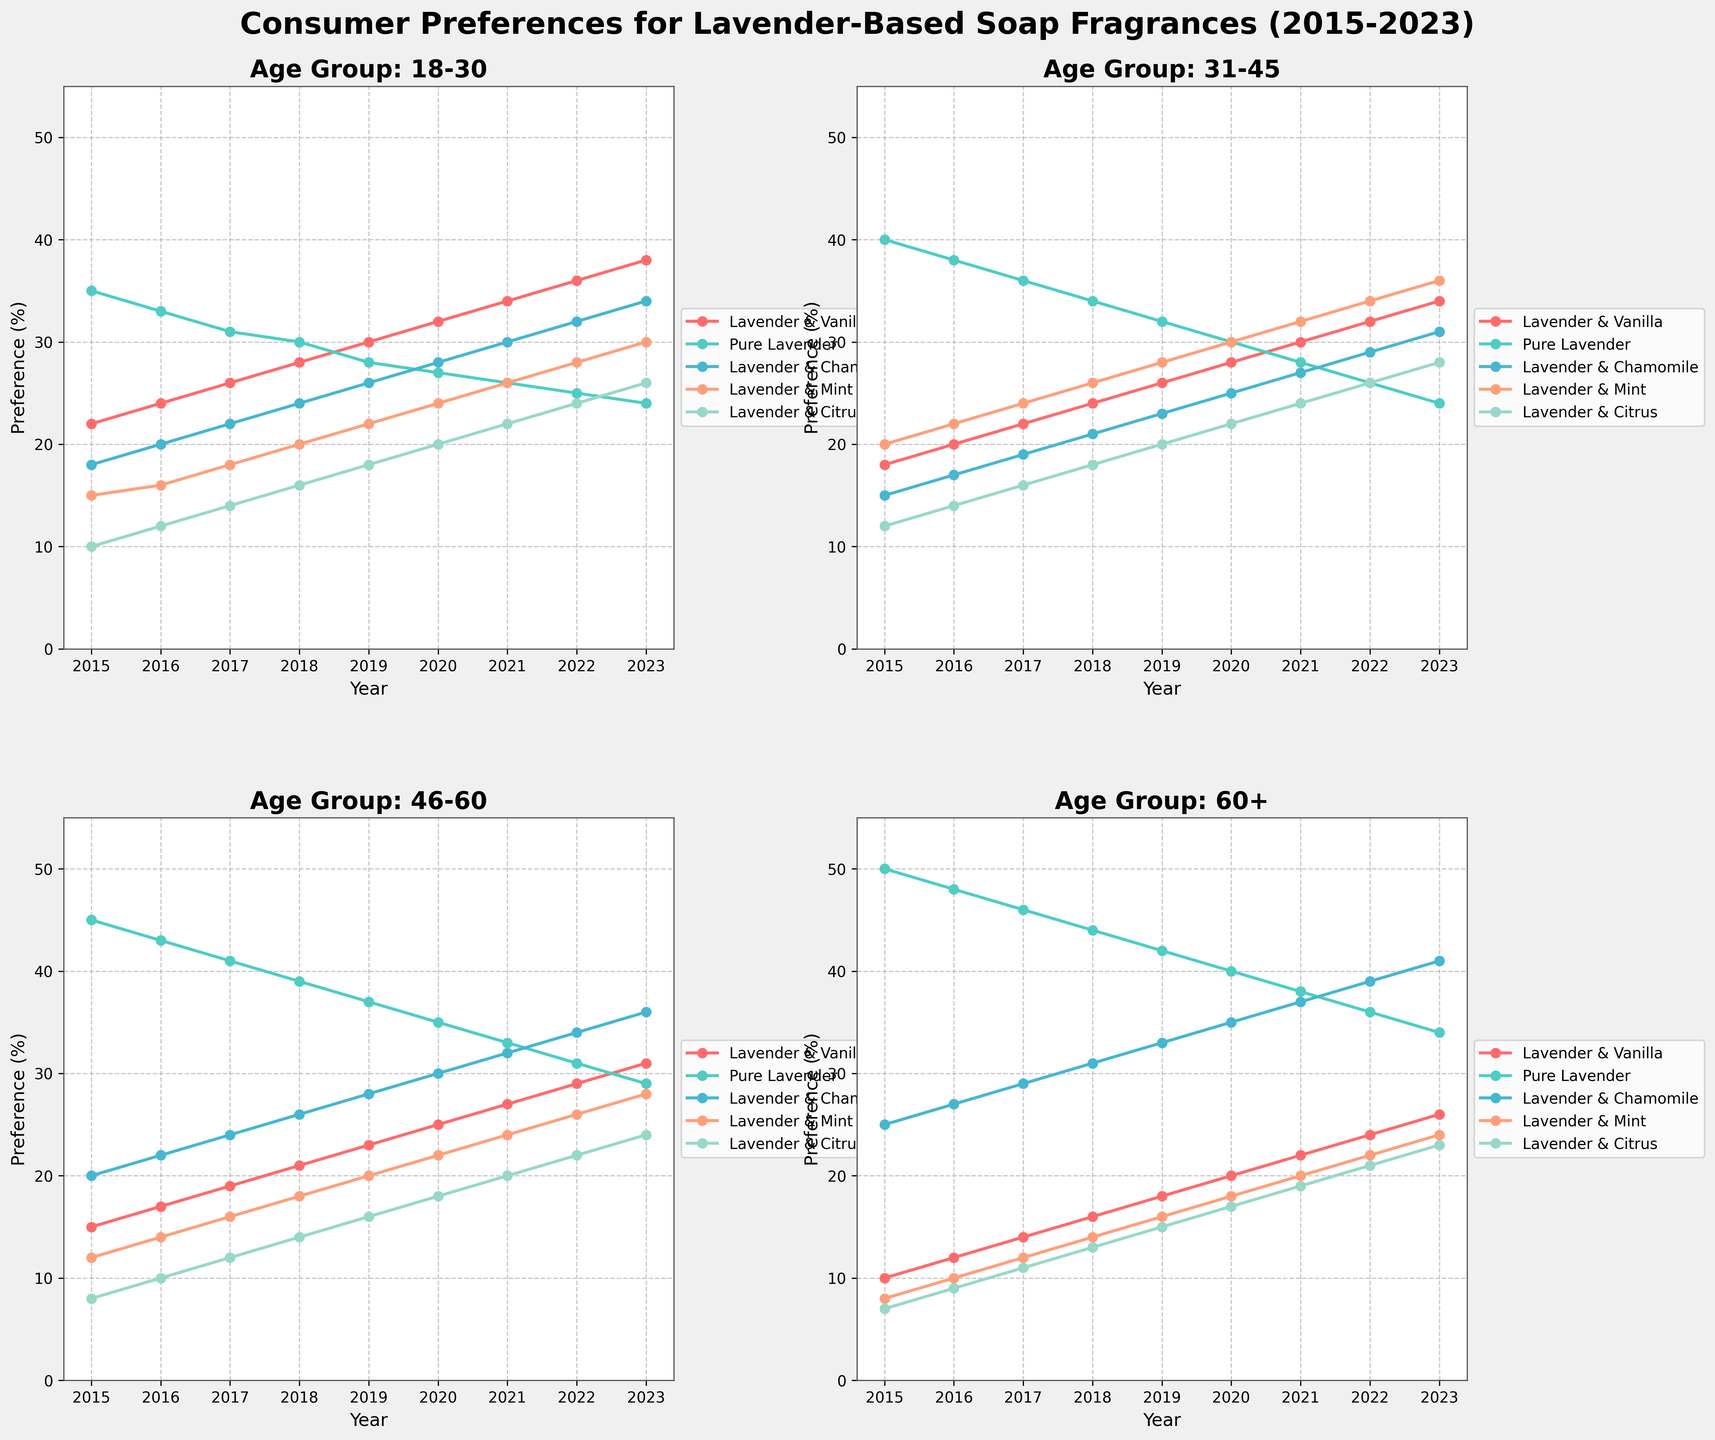Which fragrance shows the steepest increase in preference among the 18-30 age group from 2015 to 2023? To determine the steepest increase, calculate the difference between 2023 and 2015 for each fragrance within the 18-30 age group. Lavender & Vanilla increases by 16 (38-22), Pure Lavender decreases by 11 (24-35), Lavender & Chamomile increases by 16 (34-18), Lavender & Mint increases by 15 (30-15), and Lavender & Citrus increases by 16 (26-10). Although Lavender & Vanilla and Lavender & Chamomile both increase by 16, they start at different bases, making them equally steep.
Answer: Lavender & Vanilla and Lavender & Chamomile Does the preference for Pure Lavender decrease across all age groups from 2015 to 2023? For each age group, check if the preference for Pure Lavender in 2023 is less than in 2015. 18-30: 35 to 24 (decrease); 31-45: 40 to 24 (decrease); 46-60: 45 to 29 (decrease); 60+: 50 to 34 (decrease). Since all age groups show a decrease, the answer is yes.
Answer: Yes Which age group shows the highest preference for Lavender & Chamomile in 2023 and what is the value? Check the 2023 values for Lavender & Chamomile across all age groups. 18-30: 34, 31-45: 31, 46-60: 36, 60+: 41. The highest value is for the 60+ age group.
Answer: 60+, 41 How does the trend for Lavender & Mint preference compare between the 31-45 and the 46-60 age groups from 2015 to 2023? Compare the yearly values for Lavender & Mint between these two age groups. Both increase but at different rates. For 31-45, it starts at 20 in 2015 and goes to 36 in 2023. For 46-60, it starts at 12 in 2015 and goes to 28 in 2023. Both show a general upward trend.
Answer: Both increase, but 31-45 has a steeper rise What is the average preference for Lavender & Citrus in the 18-30 age group from 2015 to 2023? Calculate the sum of Lavender & Citrus values for the 18-30 age group from 2015 to 2023, then divide by the number of years (9). (10+12+14+16+18+20+22+24+26) / 9 = 17.33
Answer: 17.33 Which fragrance shows the most consistent preference (least variation) in the 46-60 age group from 2015 to 2023? Calculate the range (max-min) for each fragrance within the 46-60 age group. The fragrance with the smallest range shows the least variation. Lavender & Vanilla: (31-15)=16, Pure Lavender: (45-29)=16, Lavender & Chamomile: (36-20)=16, Lavender & Mint: (28-12)=16, Lavender & Citrus: (24-8)=16. They all show the same variation of 16.
Answer: All show equal variation In the 60+ age group, which year saw the highest preference for Lavender & Vanilla and what was the value? Check the yearly values for Lavender & Vanilla in the 60+ age group. The highest value is in 2023 at 26.
Answer: 2023, 26 